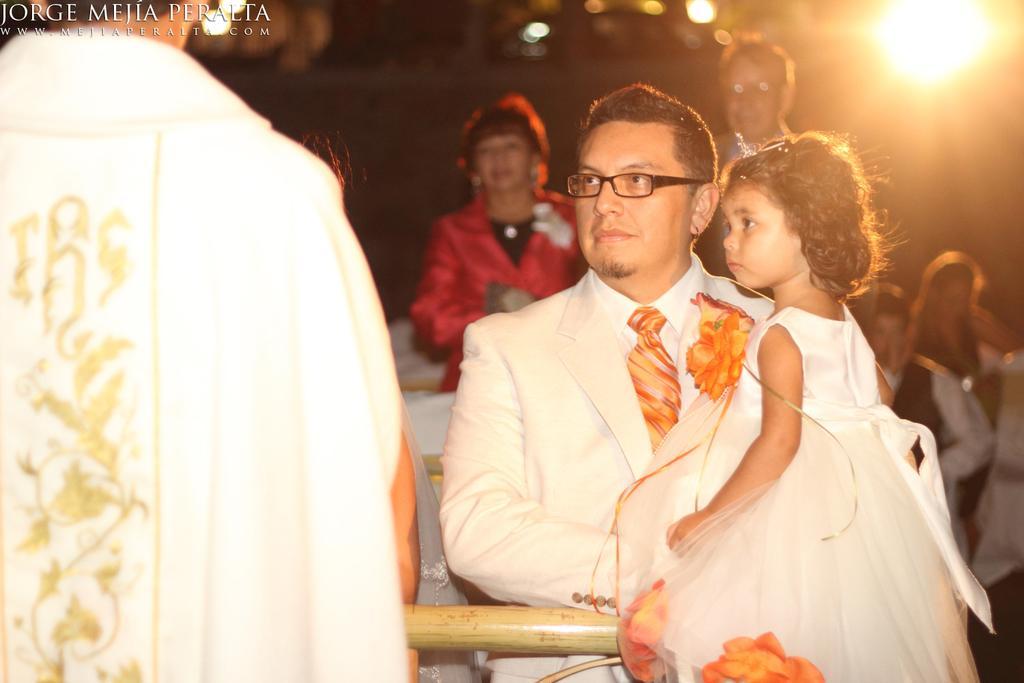Could you give a brief overview of what you see in this image? People are present. A person is holding a girl wearing a suit and an orange tie. There is a light at the back. 